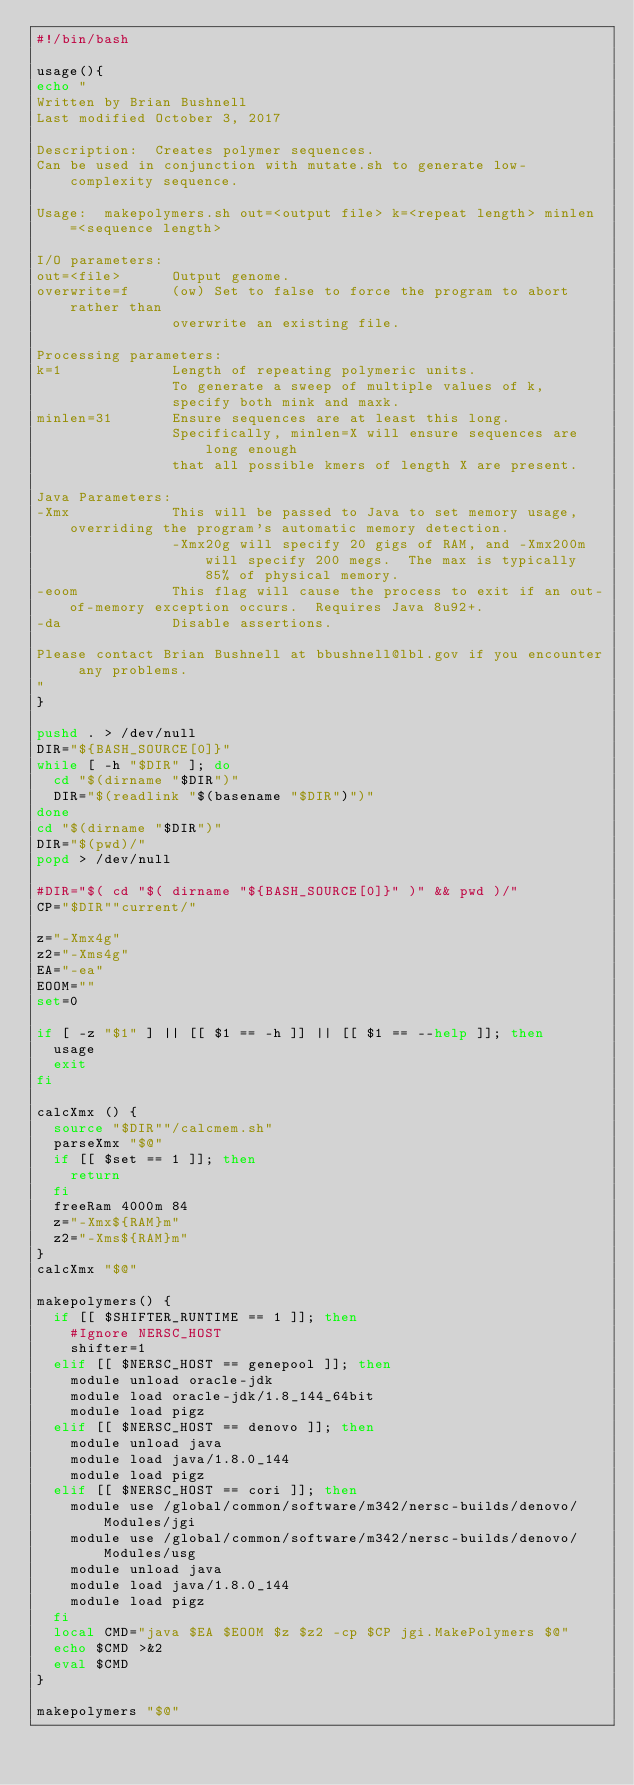Convert code to text. <code><loc_0><loc_0><loc_500><loc_500><_Bash_>#!/bin/bash

usage(){
echo "
Written by Brian Bushnell
Last modified October 3, 2017

Description:  Creates polymer sequences.
Can be used in conjunction with mutate.sh to generate low-complexity sequence.

Usage:  makepolymers.sh out=<output file> k=<repeat length> minlen=<sequence length>

I/O parameters:
out=<file>      Output genome.
overwrite=f     (ow) Set to false to force the program to abort rather than
                overwrite an existing file.

Processing parameters:
k=1             Length of repeating polymeric units.
                To generate a sweep of multiple values of k,
                specify both mink and maxk.
minlen=31       Ensure sequences are at least this long.
                Specifically, minlen=X will ensure sequences are long enough
                that all possible kmers of length X are present.

Java Parameters:
-Xmx            This will be passed to Java to set memory usage, overriding the program's automatic memory detection.
                -Xmx20g will specify 20 gigs of RAM, and -Xmx200m will specify 200 megs.  The max is typically 85% of physical memory.
-eoom           This flag will cause the process to exit if an out-of-memory exception occurs.  Requires Java 8u92+.
-da             Disable assertions.

Please contact Brian Bushnell at bbushnell@lbl.gov if you encounter any problems.
"
}

pushd . > /dev/null
DIR="${BASH_SOURCE[0]}"
while [ -h "$DIR" ]; do
  cd "$(dirname "$DIR")"
  DIR="$(readlink "$(basename "$DIR")")"
done
cd "$(dirname "$DIR")"
DIR="$(pwd)/"
popd > /dev/null

#DIR="$( cd "$( dirname "${BASH_SOURCE[0]}" )" && pwd )/"
CP="$DIR""current/"

z="-Xmx4g"
z2="-Xms4g"
EA="-ea"
EOOM=""
set=0

if [ -z "$1" ] || [[ $1 == -h ]] || [[ $1 == --help ]]; then
	usage
	exit
fi

calcXmx () {
	source "$DIR""/calcmem.sh"
	parseXmx "$@"
	if [[ $set == 1 ]]; then
		return
	fi
	freeRam 4000m 84
	z="-Xmx${RAM}m"
	z2="-Xms${RAM}m"
}
calcXmx "$@"

makepolymers() {
	if [[ $SHIFTER_RUNTIME == 1 ]]; then
		#Ignore NERSC_HOST
		shifter=1
	elif [[ $NERSC_HOST == genepool ]]; then
		module unload oracle-jdk
		module load oracle-jdk/1.8_144_64bit
		module load pigz
	elif [[ $NERSC_HOST == denovo ]]; then
		module unload java
		module load java/1.8.0_144
		module load pigz
	elif [[ $NERSC_HOST == cori ]]; then
		module use /global/common/software/m342/nersc-builds/denovo/Modules/jgi
		module use /global/common/software/m342/nersc-builds/denovo/Modules/usg
		module unload java
		module load java/1.8.0_144
		module load pigz
	fi
	local CMD="java $EA $EOOM $z $z2 -cp $CP jgi.MakePolymers $@"
	echo $CMD >&2
	eval $CMD
}

makepolymers "$@"
</code> 